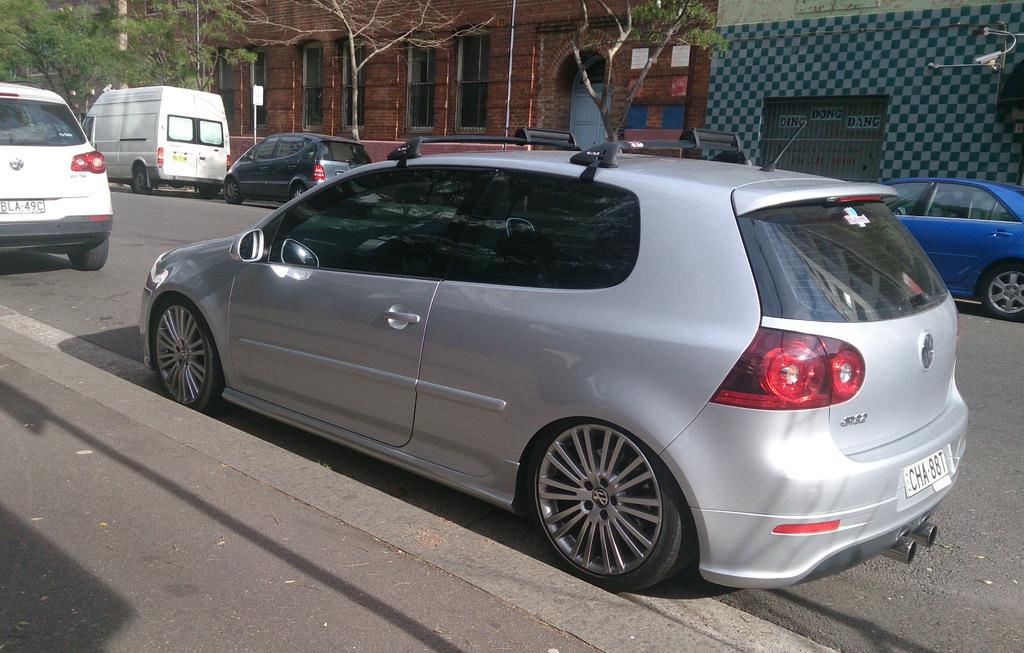What can be seen on the road in the image? There are vehicles on the road in the image. What type of structures are visible in the image? There are buildings visible in the image. What type of vegetation is present in the image? There are trees in the image. What is written or displayed on a wall in the image? There is text on a wall in the image. What type of dress is hanging on the tree in the image? There is no dress hanging on the tree in the image; only vehicles, buildings, trees, and text on a wall are present. What is the view from the top of the tallest building in the image? The image does not provide a view from the top of any building, so it cannot be determined. 